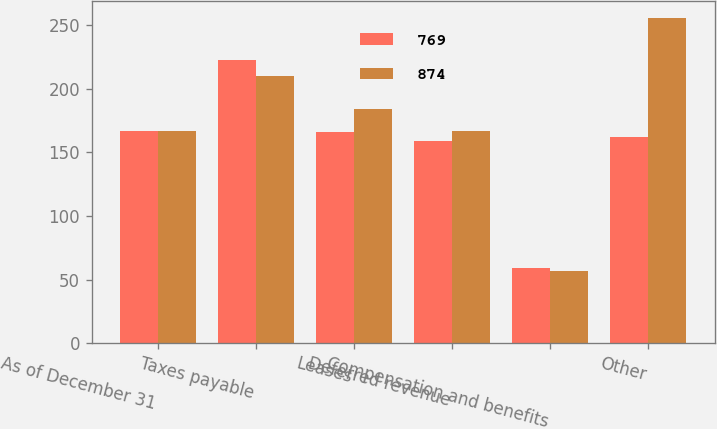Convert chart to OTSL. <chart><loc_0><loc_0><loc_500><loc_500><stacked_bar_chart><ecel><fcel>As of December 31<fcel>Taxes payable<fcel>Leases<fcel>Deferred revenue<fcel>Compensation and benefits<fcel>Other<nl><fcel>769<fcel>166.5<fcel>223<fcel>166<fcel>159<fcel>59<fcel>162<nl><fcel>874<fcel>166.5<fcel>210<fcel>184<fcel>167<fcel>57<fcel>256<nl></chart> 